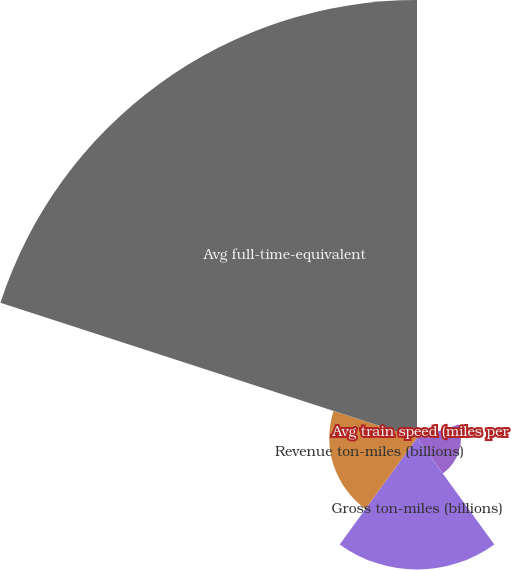<chart> <loc_0><loc_0><loc_500><loc_500><pie_chart><fcel>Avg train speed (miles per<fcel>Avg terminal dwell time<fcel>Gross ton-miles (billions)<fcel>Revenue ton-miles (billions)<fcel>Avg full-time-equivalent<nl><fcel>0.03%<fcel>6.27%<fcel>18.75%<fcel>12.51%<fcel>62.44%<nl></chart> 